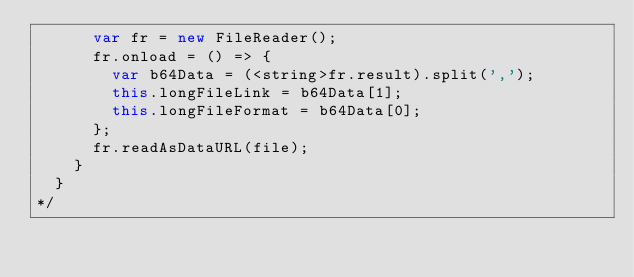<code> <loc_0><loc_0><loc_500><loc_500><_JavaScript_>      var fr = new FileReader();
      fr.onload = () => {
        var b64Data = (<string>fr.result).split(',');
        this.longFileLink = b64Data[1];
        this.longFileFormat = b64Data[0];
      };
      fr.readAsDataURL(file);
    }
  }
*/</code> 